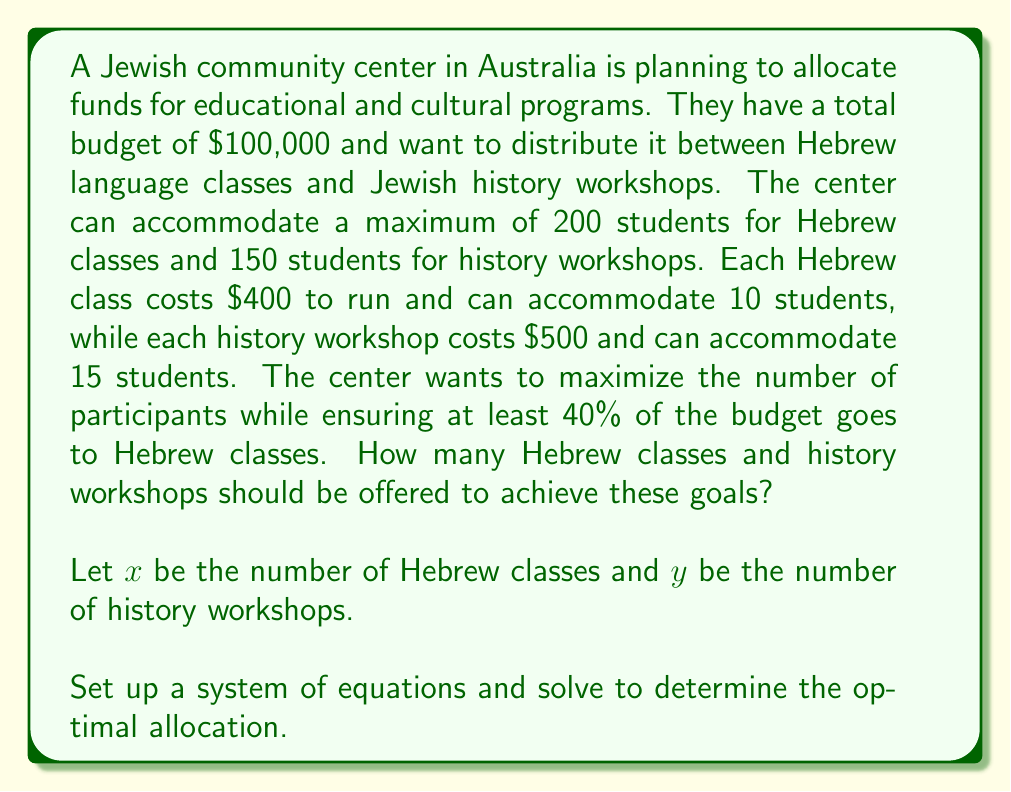What is the answer to this math problem? Let's approach this step-by-step:

1) First, let's set up our constraints:

   Budget constraint: $400x + 500y \leq 100000$
   Hebrew class capacity: $10x \leq 200$
   History workshop capacity: $15y \leq 150$
   Minimum Hebrew class budget: $400x \geq 0.4(100000)$

2) Simplify these constraints:

   $400x + 500y \leq 100000$
   $x \leq 20$
   $y \leq 10$
   $400x \geq 40000$ or $x \geq 100$

3) From the Hebrew class budget requirement, we know $x \geq 100$. But this contradicts $x \leq 20$ from the capacity constraint. This means we need to use the maximum capacity for Hebrew classes, so $x = 20$.

4) Substituting this into our budget constraint:

   $400(20) + 500y \leq 100000$
   $8000 + 500y \leq 100000$
   $500y \leq 92000$
   $y \leq 184$

5) But we also have the constraint $y \leq 10$ from the history workshop capacity.

6) Therefore, the maximum value for $y$ is 10.

7) Let's verify if this solution satisfies all constraints:

   Budget: $400(20) + 500(10) = 8000 + 5000 = 13000 \leq 100000$ (satisfied)
   Hebrew class capacity: $10(20) = 200 \leq 200$ (satisfied)
   History workshop capacity: $15(10) = 150 \leq 150$ (satisfied)
   Minimum Hebrew class budget: $8000 > 40000$ (satisfied)

Therefore, the optimal allocation is 20 Hebrew classes and 10 history workshops.
Answer: The optimal allocation is 20 Hebrew classes and 10 history workshops. 